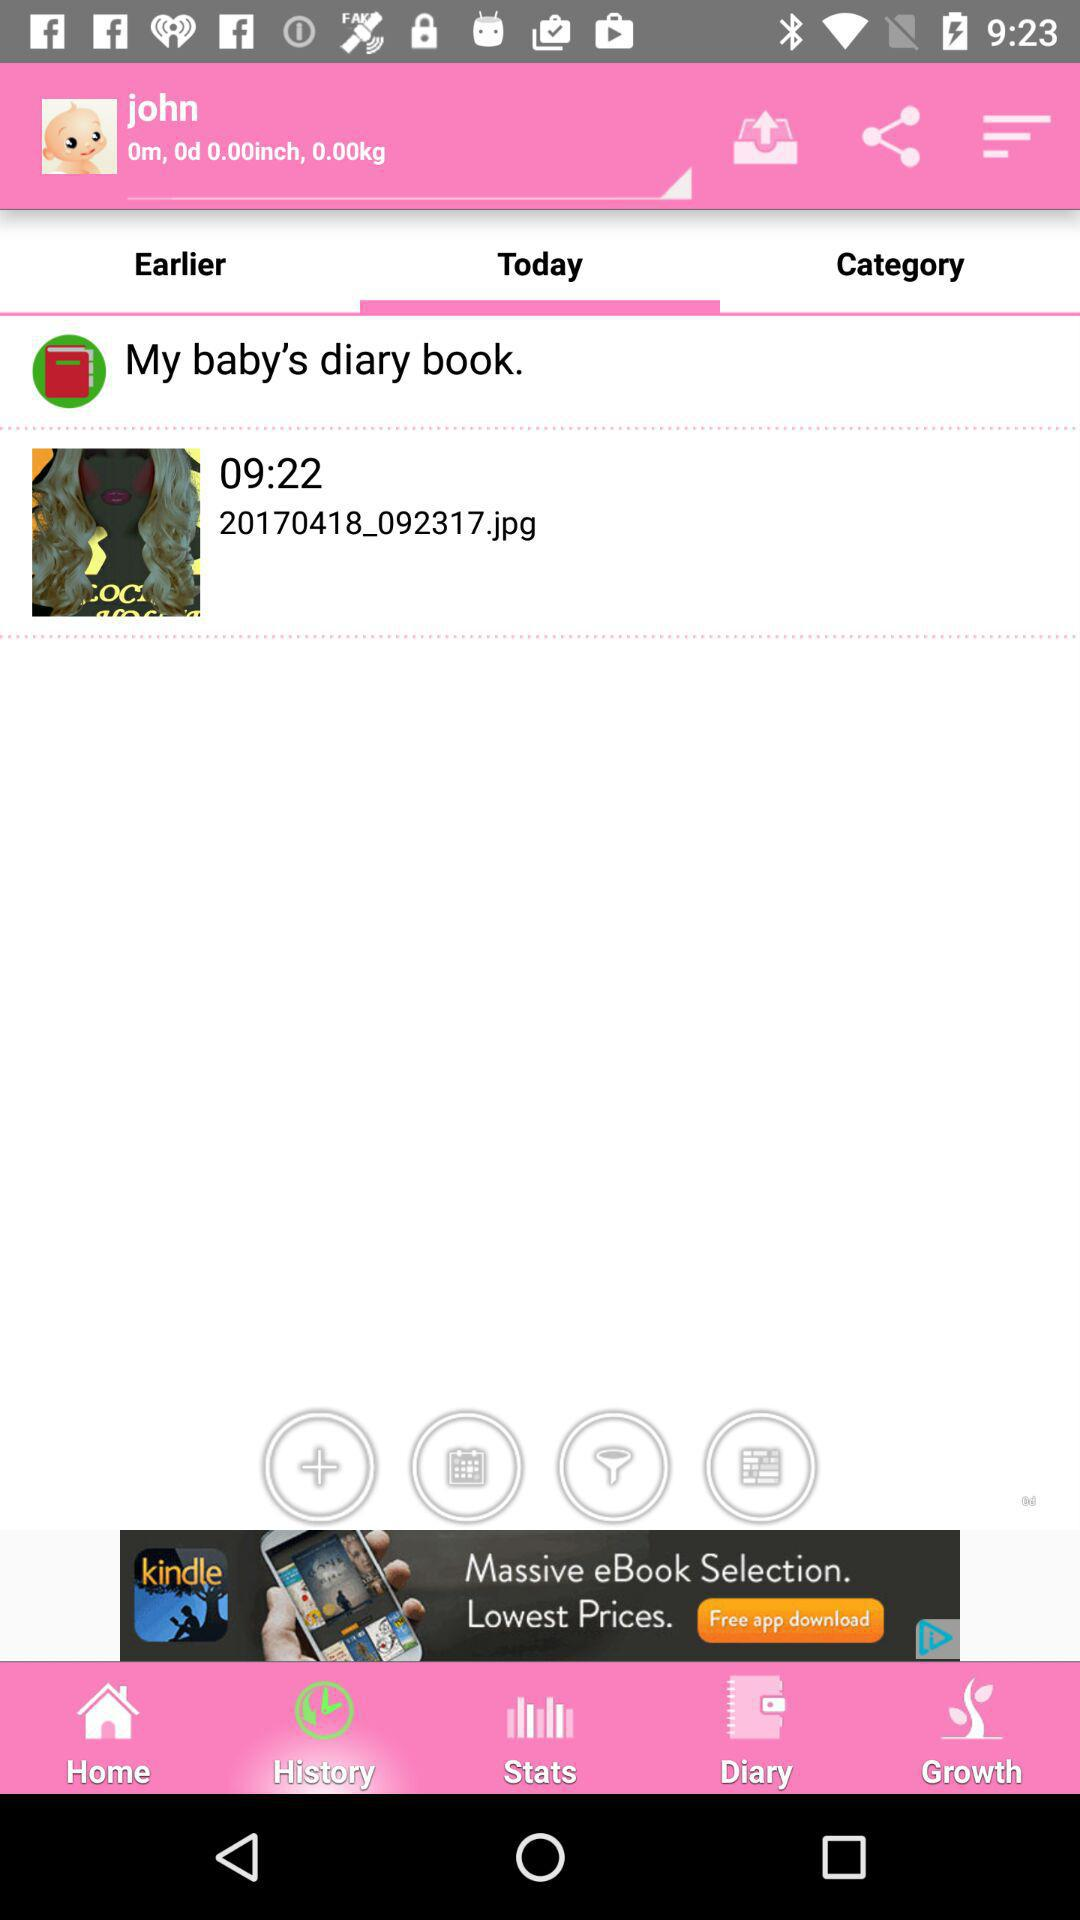Which tab is selected? The selected tab is "Today". 